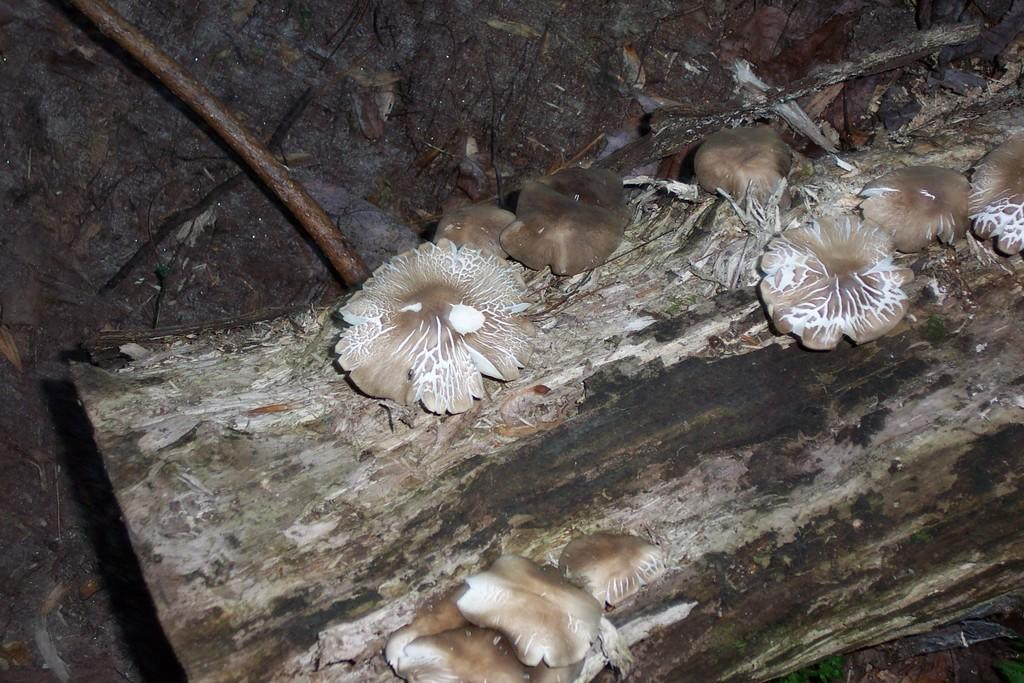What type of fungi can be seen in the image? There are mushrooms in the image. Where are the mushrooms located? The mushrooms are on a wooden board. What other natural element is present in the image? There is a branch in the image. What can be seen in the background of the image? There is a wall visible in the background of the image. What type of science experiment is being conducted with the mushrooms in the image? There is no indication of a science experiment in the image; it simply shows mushrooms on a wooden board. Can you tell me who owns the property where the mushrooms are located? The image does not provide any information about the ownership of the property where the mushrooms are located. 